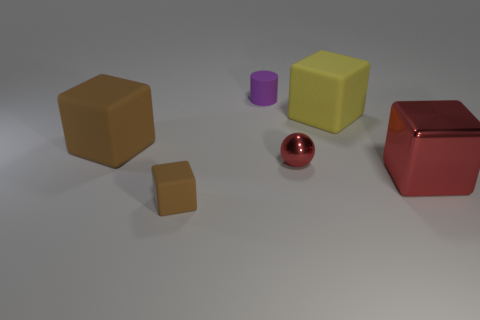Subtract all gray cylinders. Subtract all cyan balls. How many cylinders are left? 1 Add 1 tiny purple cylinders. How many objects exist? 7 Subtract all cylinders. How many objects are left? 5 Subtract 0 red cylinders. How many objects are left? 6 Subtract all yellow rubber cubes. Subtract all big yellow things. How many objects are left? 4 Add 5 purple cylinders. How many purple cylinders are left? 6 Add 6 shiny blocks. How many shiny blocks exist? 7 